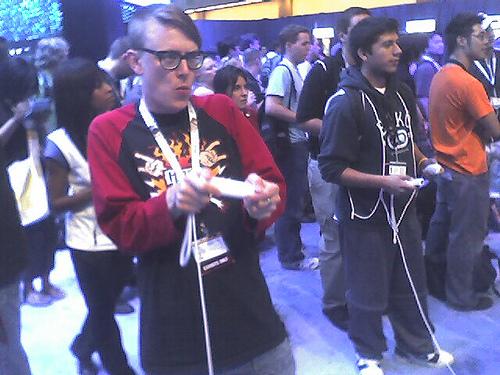Is this mostly a young crowd?
Be succinct. Yes. Is this some type of convention?
Answer briefly. Yes. Are these all men?
Keep it brief. No. What are these people looking at?
Answer briefly. Television. 